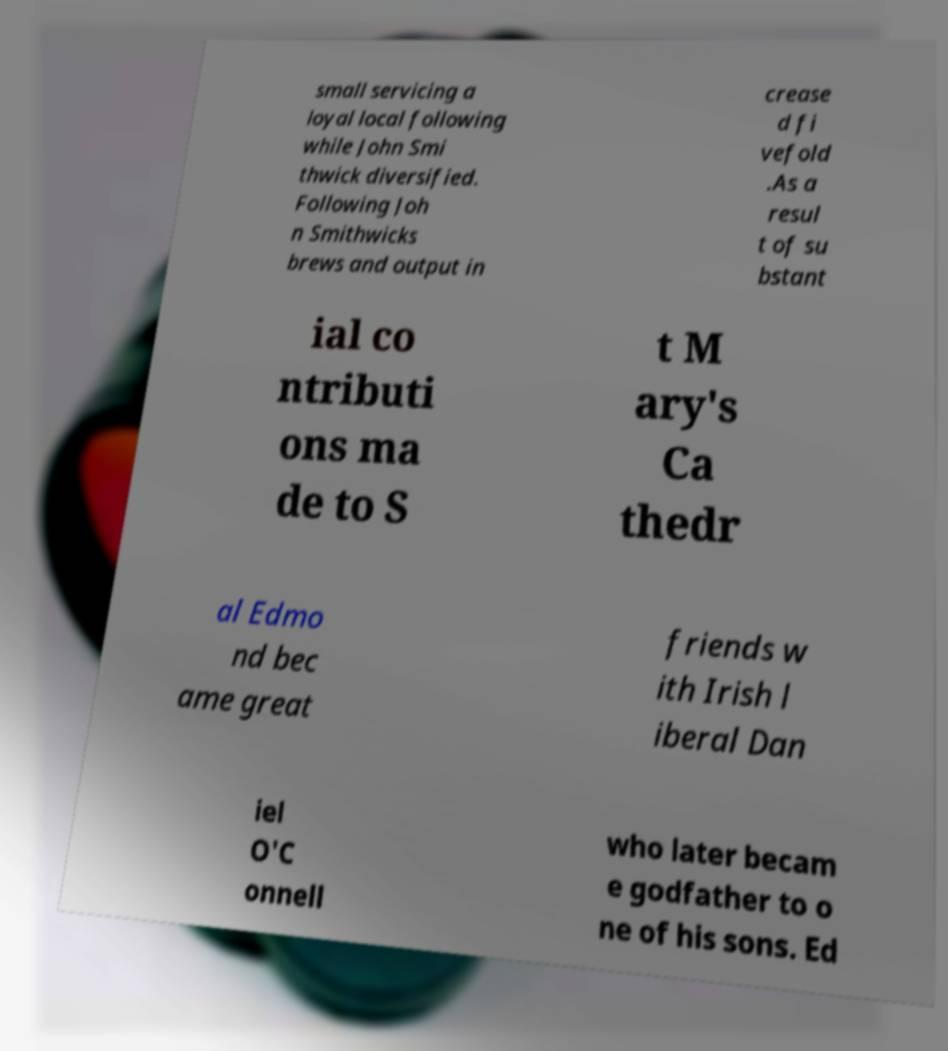I need the written content from this picture converted into text. Can you do that? small servicing a loyal local following while John Smi thwick diversified. Following Joh n Smithwicks brews and output in crease d fi vefold .As a resul t of su bstant ial co ntributi ons ma de to S t M ary's Ca thedr al Edmo nd bec ame great friends w ith Irish l iberal Dan iel O'C onnell who later becam e godfather to o ne of his sons. Ed 